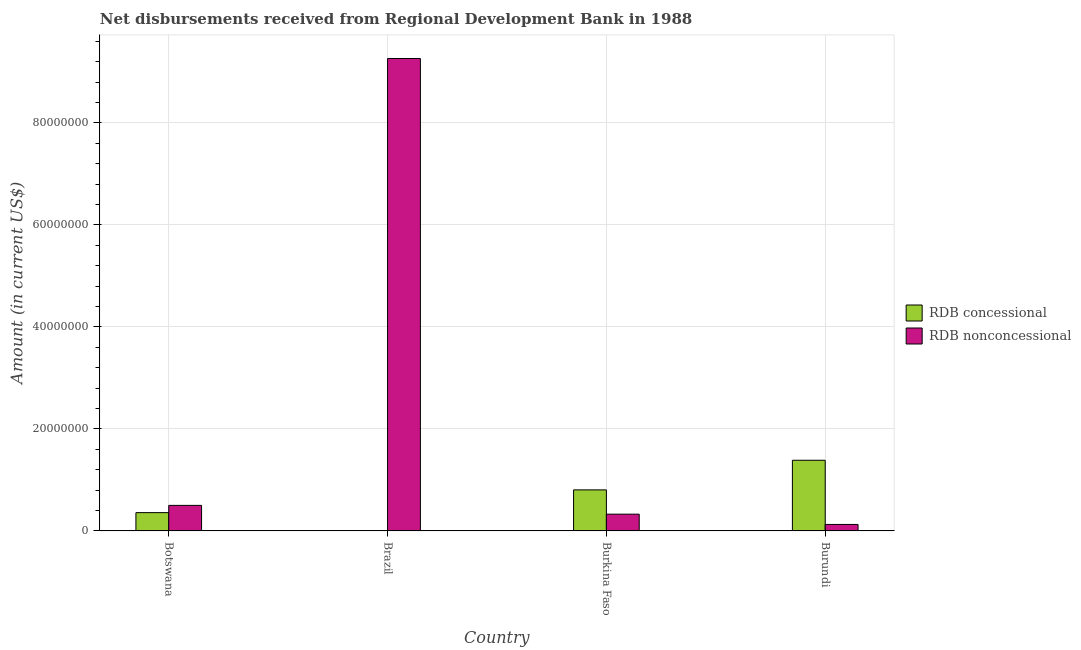How many different coloured bars are there?
Offer a very short reply. 2. Are the number of bars per tick equal to the number of legend labels?
Make the answer very short. No. How many bars are there on the 2nd tick from the right?
Your response must be concise. 2. What is the label of the 3rd group of bars from the left?
Your answer should be compact. Burkina Faso. In how many cases, is the number of bars for a given country not equal to the number of legend labels?
Provide a short and direct response. 1. What is the net concessional disbursements from rdb in Burundi?
Keep it short and to the point. 1.39e+07. Across all countries, what is the maximum net concessional disbursements from rdb?
Your response must be concise. 1.39e+07. Across all countries, what is the minimum net non concessional disbursements from rdb?
Provide a short and direct response. 1.27e+06. In which country was the net concessional disbursements from rdb maximum?
Provide a succinct answer. Burundi. What is the total net non concessional disbursements from rdb in the graph?
Your answer should be very brief. 1.02e+08. What is the difference between the net non concessional disbursements from rdb in Botswana and that in Brazil?
Ensure brevity in your answer.  -8.76e+07. What is the difference between the net concessional disbursements from rdb in Burkina Faso and the net non concessional disbursements from rdb in Botswana?
Provide a succinct answer. 3.04e+06. What is the average net non concessional disbursements from rdb per country?
Your answer should be very brief. 2.55e+07. What is the difference between the net non concessional disbursements from rdb and net concessional disbursements from rdb in Burkina Faso?
Offer a terse response. -4.76e+06. What is the ratio of the net non concessional disbursements from rdb in Brazil to that in Burundi?
Provide a succinct answer. 72.81. Is the net non concessional disbursements from rdb in Botswana less than that in Brazil?
Your response must be concise. Yes. What is the difference between the highest and the second highest net concessional disbursements from rdb?
Provide a short and direct response. 5.81e+06. What is the difference between the highest and the lowest net concessional disbursements from rdb?
Your answer should be very brief. 1.39e+07. Are all the bars in the graph horizontal?
Offer a very short reply. No. What is the difference between two consecutive major ticks on the Y-axis?
Your answer should be compact. 2.00e+07. Are the values on the major ticks of Y-axis written in scientific E-notation?
Provide a short and direct response. No. Does the graph contain grids?
Your answer should be compact. Yes. Where does the legend appear in the graph?
Ensure brevity in your answer.  Center right. How many legend labels are there?
Make the answer very short. 2. How are the legend labels stacked?
Offer a very short reply. Vertical. What is the title of the graph?
Make the answer very short. Net disbursements received from Regional Development Bank in 1988. Does "Commercial service imports" appear as one of the legend labels in the graph?
Ensure brevity in your answer.  No. What is the label or title of the Y-axis?
Provide a short and direct response. Amount (in current US$). What is the Amount (in current US$) of RDB concessional in Botswana?
Provide a short and direct response. 3.59e+06. What is the Amount (in current US$) of RDB nonconcessional in Botswana?
Offer a terse response. 5.01e+06. What is the Amount (in current US$) of RDB concessional in Brazil?
Provide a short and direct response. 0. What is the Amount (in current US$) in RDB nonconcessional in Brazil?
Your response must be concise. 9.26e+07. What is the Amount (in current US$) in RDB concessional in Burkina Faso?
Keep it short and to the point. 8.05e+06. What is the Amount (in current US$) in RDB nonconcessional in Burkina Faso?
Offer a terse response. 3.29e+06. What is the Amount (in current US$) of RDB concessional in Burundi?
Your response must be concise. 1.39e+07. What is the Amount (in current US$) in RDB nonconcessional in Burundi?
Provide a succinct answer. 1.27e+06. Across all countries, what is the maximum Amount (in current US$) of RDB concessional?
Offer a very short reply. 1.39e+07. Across all countries, what is the maximum Amount (in current US$) in RDB nonconcessional?
Make the answer very short. 9.26e+07. Across all countries, what is the minimum Amount (in current US$) in RDB concessional?
Make the answer very short. 0. Across all countries, what is the minimum Amount (in current US$) of RDB nonconcessional?
Give a very brief answer. 1.27e+06. What is the total Amount (in current US$) in RDB concessional in the graph?
Your answer should be compact. 2.55e+07. What is the total Amount (in current US$) in RDB nonconcessional in the graph?
Give a very brief answer. 1.02e+08. What is the difference between the Amount (in current US$) of RDB nonconcessional in Botswana and that in Brazil?
Offer a very short reply. -8.76e+07. What is the difference between the Amount (in current US$) of RDB concessional in Botswana and that in Burkina Faso?
Ensure brevity in your answer.  -4.46e+06. What is the difference between the Amount (in current US$) of RDB nonconcessional in Botswana and that in Burkina Faso?
Your response must be concise. 1.72e+06. What is the difference between the Amount (in current US$) of RDB concessional in Botswana and that in Burundi?
Make the answer very short. -1.03e+07. What is the difference between the Amount (in current US$) of RDB nonconcessional in Botswana and that in Burundi?
Offer a terse response. 3.74e+06. What is the difference between the Amount (in current US$) of RDB nonconcessional in Brazil and that in Burkina Faso?
Your response must be concise. 8.93e+07. What is the difference between the Amount (in current US$) of RDB nonconcessional in Brazil and that in Burundi?
Offer a very short reply. 9.13e+07. What is the difference between the Amount (in current US$) of RDB concessional in Burkina Faso and that in Burundi?
Keep it short and to the point. -5.81e+06. What is the difference between the Amount (in current US$) of RDB nonconcessional in Burkina Faso and that in Burundi?
Make the answer very short. 2.02e+06. What is the difference between the Amount (in current US$) in RDB concessional in Botswana and the Amount (in current US$) in RDB nonconcessional in Brazil?
Provide a succinct answer. -8.90e+07. What is the difference between the Amount (in current US$) in RDB concessional in Botswana and the Amount (in current US$) in RDB nonconcessional in Burkina Faso?
Give a very brief answer. 3.01e+05. What is the difference between the Amount (in current US$) of RDB concessional in Botswana and the Amount (in current US$) of RDB nonconcessional in Burundi?
Provide a succinct answer. 2.32e+06. What is the difference between the Amount (in current US$) in RDB concessional in Burkina Faso and the Amount (in current US$) in RDB nonconcessional in Burundi?
Make the answer very short. 6.78e+06. What is the average Amount (in current US$) of RDB concessional per country?
Provide a short and direct response. 6.37e+06. What is the average Amount (in current US$) of RDB nonconcessional per country?
Offer a terse response. 2.55e+07. What is the difference between the Amount (in current US$) in RDB concessional and Amount (in current US$) in RDB nonconcessional in Botswana?
Offer a very short reply. -1.42e+06. What is the difference between the Amount (in current US$) in RDB concessional and Amount (in current US$) in RDB nonconcessional in Burkina Faso?
Provide a succinct answer. 4.76e+06. What is the difference between the Amount (in current US$) of RDB concessional and Amount (in current US$) of RDB nonconcessional in Burundi?
Offer a very short reply. 1.26e+07. What is the ratio of the Amount (in current US$) of RDB nonconcessional in Botswana to that in Brazil?
Your response must be concise. 0.05. What is the ratio of the Amount (in current US$) of RDB concessional in Botswana to that in Burkina Faso?
Ensure brevity in your answer.  0.45. What is the ratio of the Amount (in current US$) in RDB nonconcessional in Botswana to that in Burkina Faso?
Your response must be concise. 1.52. What is the ratio of the Amount (in current US$) in RDB concessional in Botswana to that in Burundi?
Make the answer very short. 0.26. What is the ratio of the Amount (in current US$) of RDB nonconcessional in Botswana to that in Burundi?
Offer a very short reply. 3.94. What is the ratio of the Amount (in current US$) in RDB nonconcessional in Brazil to that in Burkina Faso?
Your answer should be very brief. 28.17. What is the ratio of the Amount (in current US$) of RDB nonconcessional in Brazil to that in Burundi?
Offer a very short reply. 72.81. What is the ratio of the Amount (in current US$) in RDB concessional in Burkina Faso to that in Burundi?
Your answer should be very brief. 0.58. What is the ratio of the Amount (in current US$) in RDB nonconcessional in Burkina Faso to that in Burundi?
Ensure brevity in your answer.  2.58. What is the difference between the highest and the second highest Amount (in current US$) of RDB concessional?
Your answer should be very brief. 5.81e+06. What is the difference between the highest and the second highest Amount (in current US$) in RDB nonconcessional?
Ensure brevity in your answer.  8.76e+07. What is the difference between the highest and the lowest Amount (in current US$) in RDB concessional?
Your response must be concise. 1.39e+07. What is the difference between the highest and the lowest Amount (in current US$) in RDB nonconcessional?
Your response must be concise. 9.13e+07. 